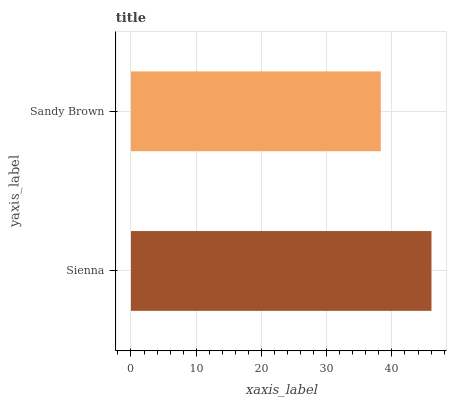Is Sandy Brown the minimum?
Answer yes or no. Yes. Is Sienna the maximum?
Answer yes or no. Yes. Is Sandy Brown the maximum?
Answer yes or no. No. Is Sienna greater than Sandy Brown?
Answer yes or no. Yes. Is Sandy Brown less than Sienna?
Answer yes or no. Yes. Is Sandy Brown greater than Sienna?
Answer yes or no. No. Is Sienna less than Sandy Brown?
Answer yes or no. No. Is Sienna the high median?
Answer yes or no. Yes. Is Sandy Brown the low median?
Answer yes or no. Yes. Is Sandy Brown the high median?
Answer yes or no. No. Is Sienna the low median?
Answer yes or no. No. 